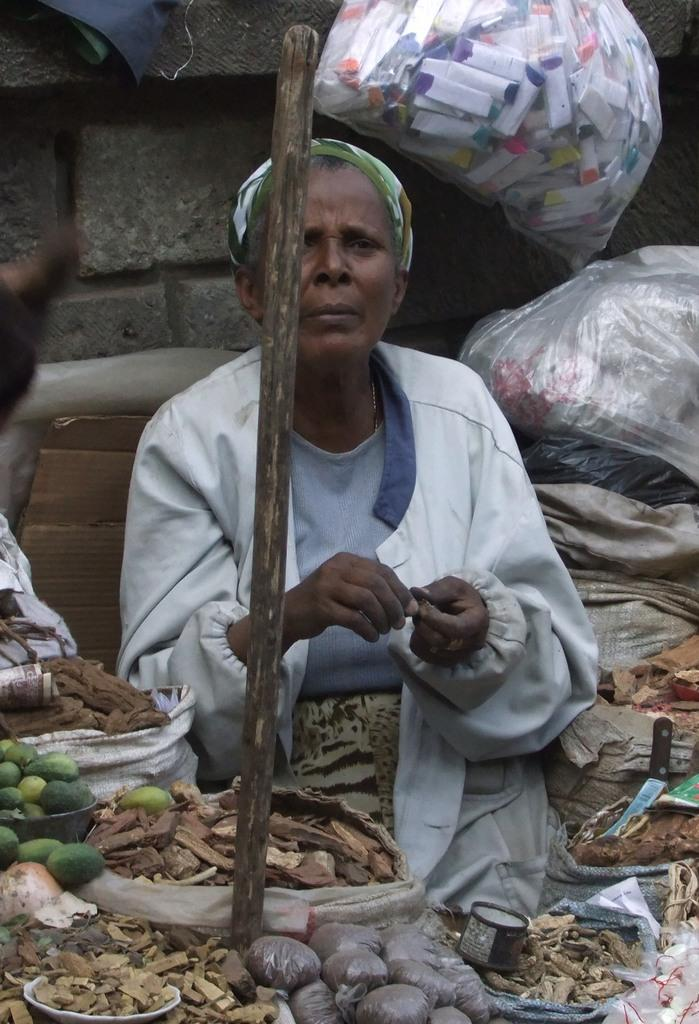What is the person in the image doing? The person is sitting and selling food items. What can be seen in the background of the image? There is a wall in the background of the image. Is the person's father present in the image? There is no mention of a father or any other person in the image, so it cannot be determined if the person's father is present. 